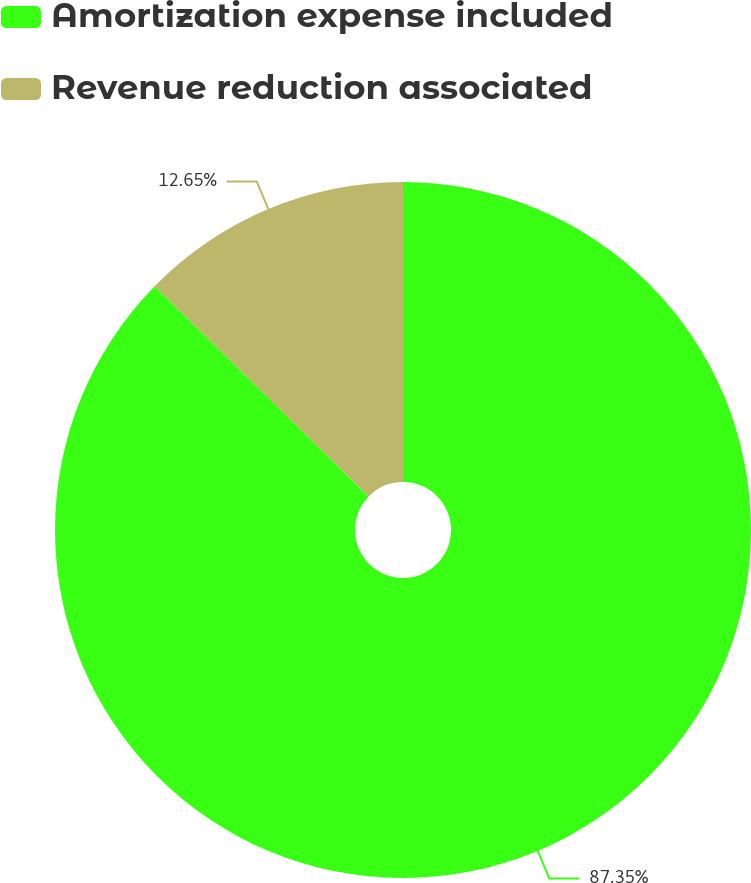Convert chart to OTSL. <chart><loc_0><loc_0><loc_500><loc_500><pie_chart><fcel>Amortization expense included<fcel>Revenue reduction associated<nl><fcel>87.35%<fcel>12.65%<nl></chart> 